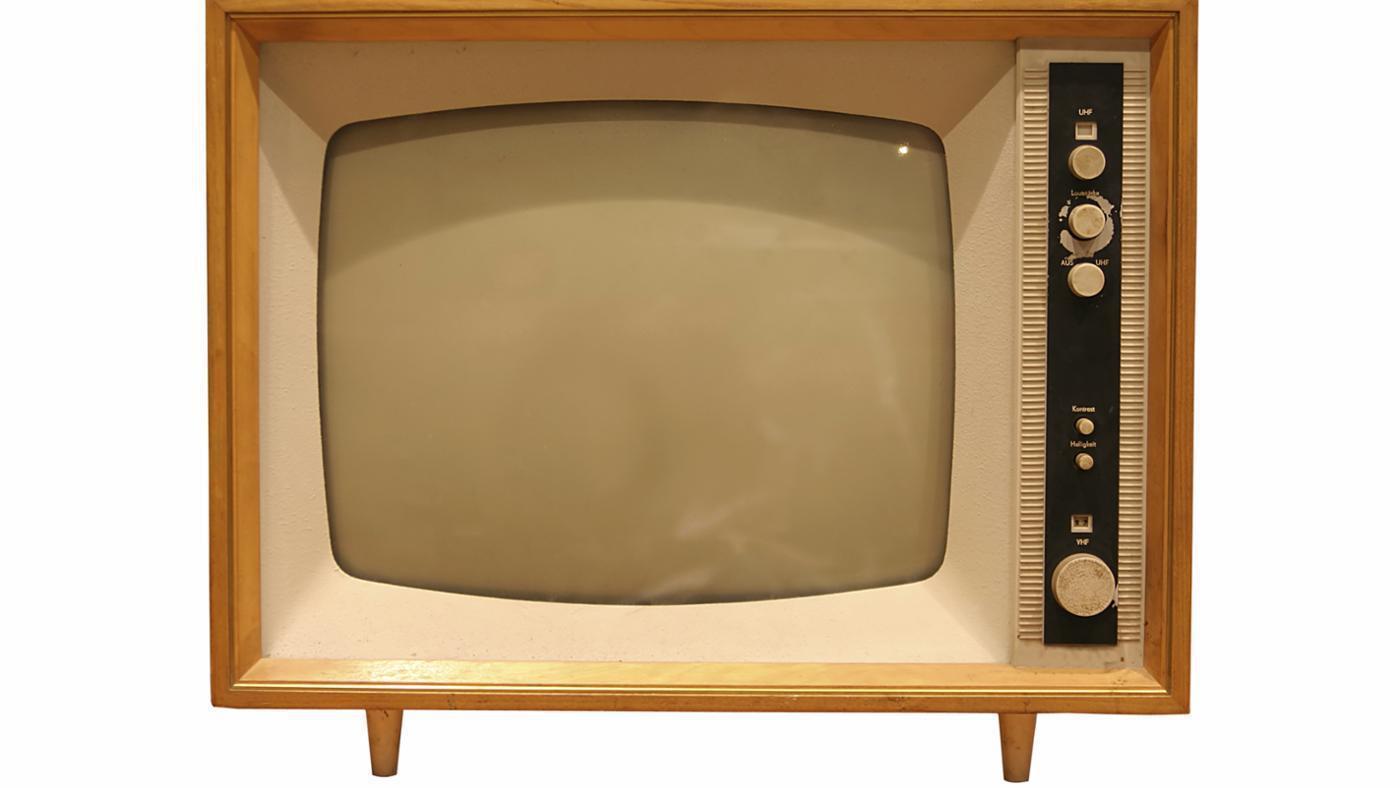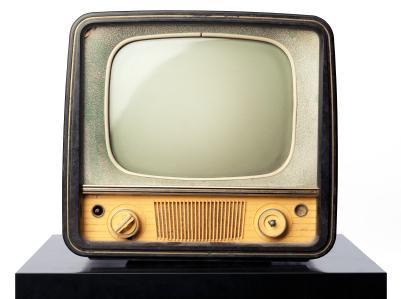The first image is the image on the left, the second image is the image on the right. For the images displayed, is the sentence "There is an antique television in the center of both of the images." factually correct? Answer yes or no. Yes. The first image is the image on the left, the second image is the image on the right. Analyze the images presented: Is the assertion "In one image, a TV has a screen with left and right sides that are curved outward and a flat top and bottom." valid? Answer yes or no. No. 